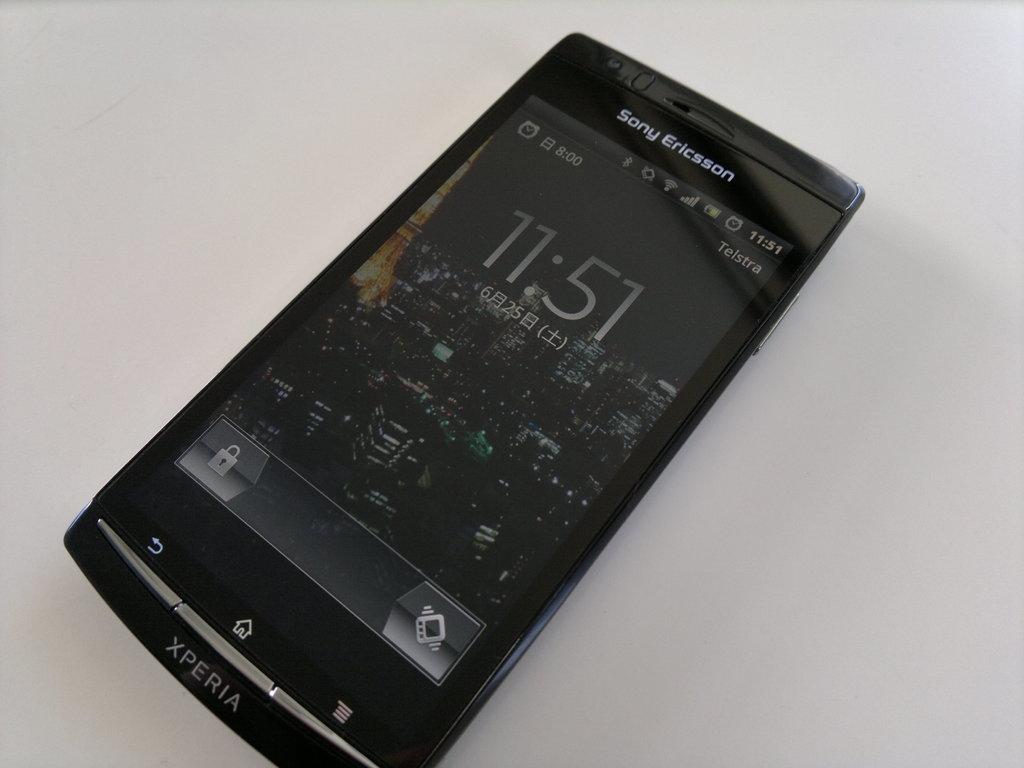What time is shown on the phone?
Your answer should be very brief. 11:51. Is xperia a brand of sony?
Provide a short and direct response. Yes. 